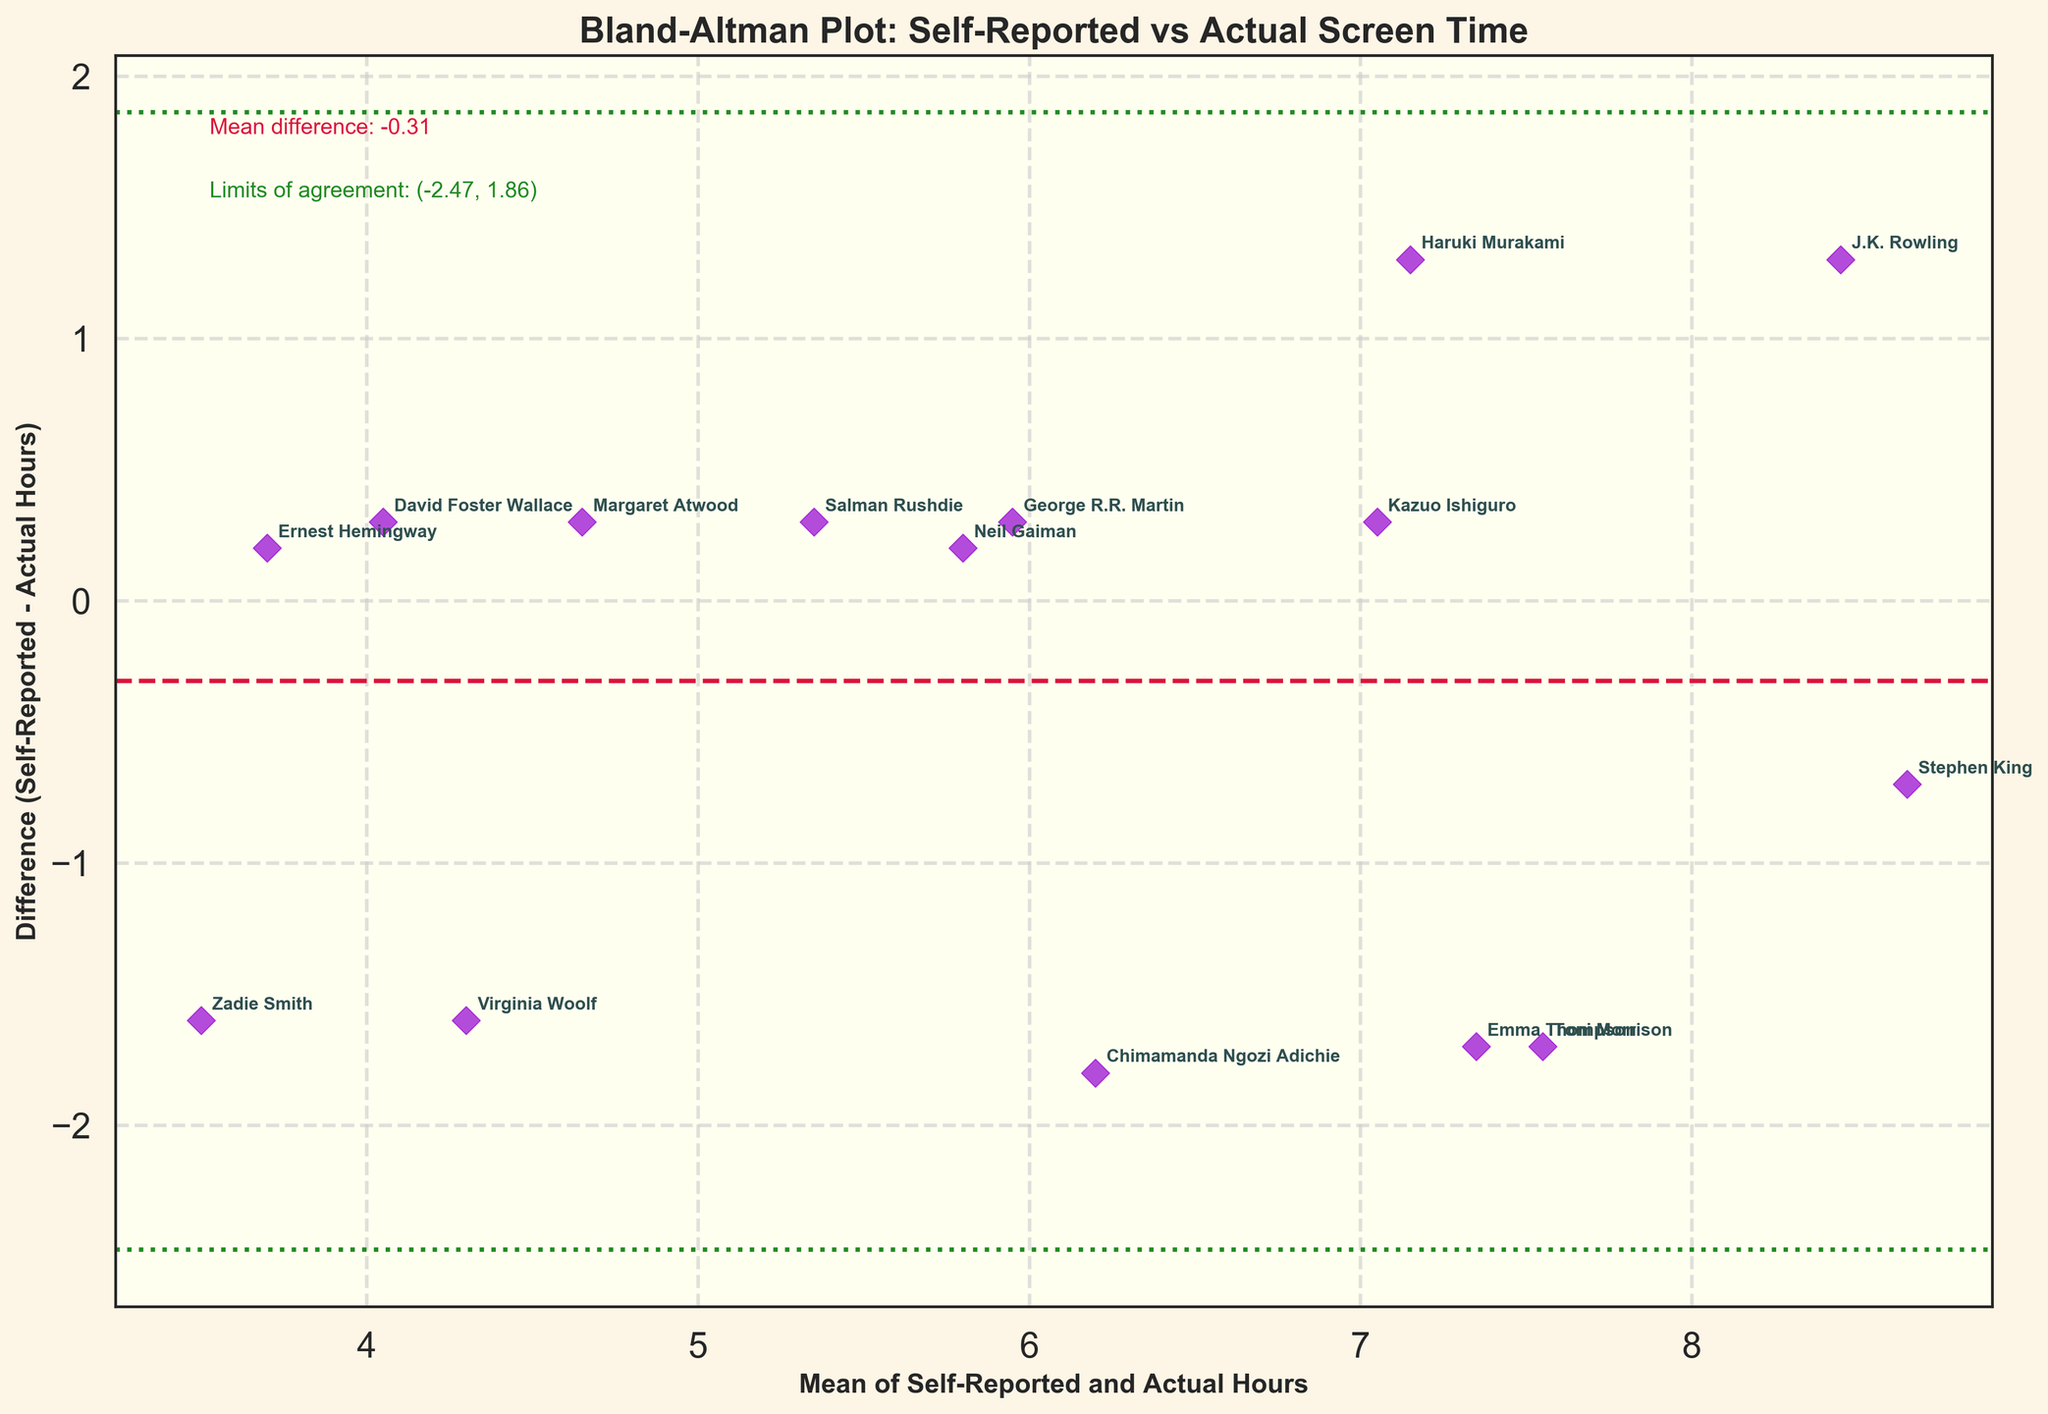What's the title of the plot? The title of the plot is usually displayed at the top of the figure for easy identification. It provides a brief description of what the plot is showcasing. In this plot, the title is "Bland-Altman Plot: Self-Reported vs Actual Screen Time".
Answer: Bland-Altman Plot: Self-Reported vs Actual Screen Time What is represented on the x-axis? The x-axis label is "Mean of Self-Reported and Actual Hours", indicating that the horizontal axis shows the average of self-reported and actual screen time for each writer.
Answer: Mean of Self-Reported and Actual Hours What is represented on the y-axis? The y-axis label "Difference (Self-Reported - Actual Hours)" suggests that the vertical axis displays the difference between self-reported and actual screen time for each writer.
Answer: Difference (Self-Reported - Actual Hours) Which writer has the largest positive difference between self-reported and actual screen time? By observing the scatter points along the y-axis, we note the highest point above zero. The writer at this maximum positive difference is Emma Thompson.
Answer: Emma Thompson Which writer has the smallest negative difference between self-reported and actual screen time? By looking for the scatter point with the smallest value below zero, we identify Chimamanda Ngozi Adichie as the writer with the smallest negative difference.
Answer: Chimamanda Ngozi Adichie What are the limits of agreement shown in the plot? The limits of agreement are plotted as horizontal lines on the y-axis, typically indicated by a particular color or linestyle. These lines establish a range that most differences will lie within. Here, they are shown as dotted green lines and labeled, with values approximately at -2.11 and 3.41.
Answer: -2.11 and 3.41 What is the mean difference between self-reported and actual screen time in this plot? The mean difference is shown as a dashed red line crossing the y-axis and usually labeled in the plot. In this case, the mean difference is approximately 0.65.
Answer: 0.65 How many writers have a positive difference between their self-reported and actual screen time? Count the number of scatter points above the mean difference line (positive values on the y-axis) to determine how many writers reported higher screen time than actual. There are 9 such writers.
Answer: 9 Does Stephen King's self-reported screen time overestimate or underestimate the actual screen time? By finding Stephen King's scatter point (annotated on the plot) and seeing if it lies above or below the zero line, we can determine that it lies below, indicating an underestimation.
Answer: Underestimate Is the majority of data points within the limits of agreement? Count the scatter points that fall within the limits of agreement lines on the y-axis. The majority can be confirmed if most points lie within these limits. All 15 points are within the limits, so the answer is yes.
Answer: Yes 